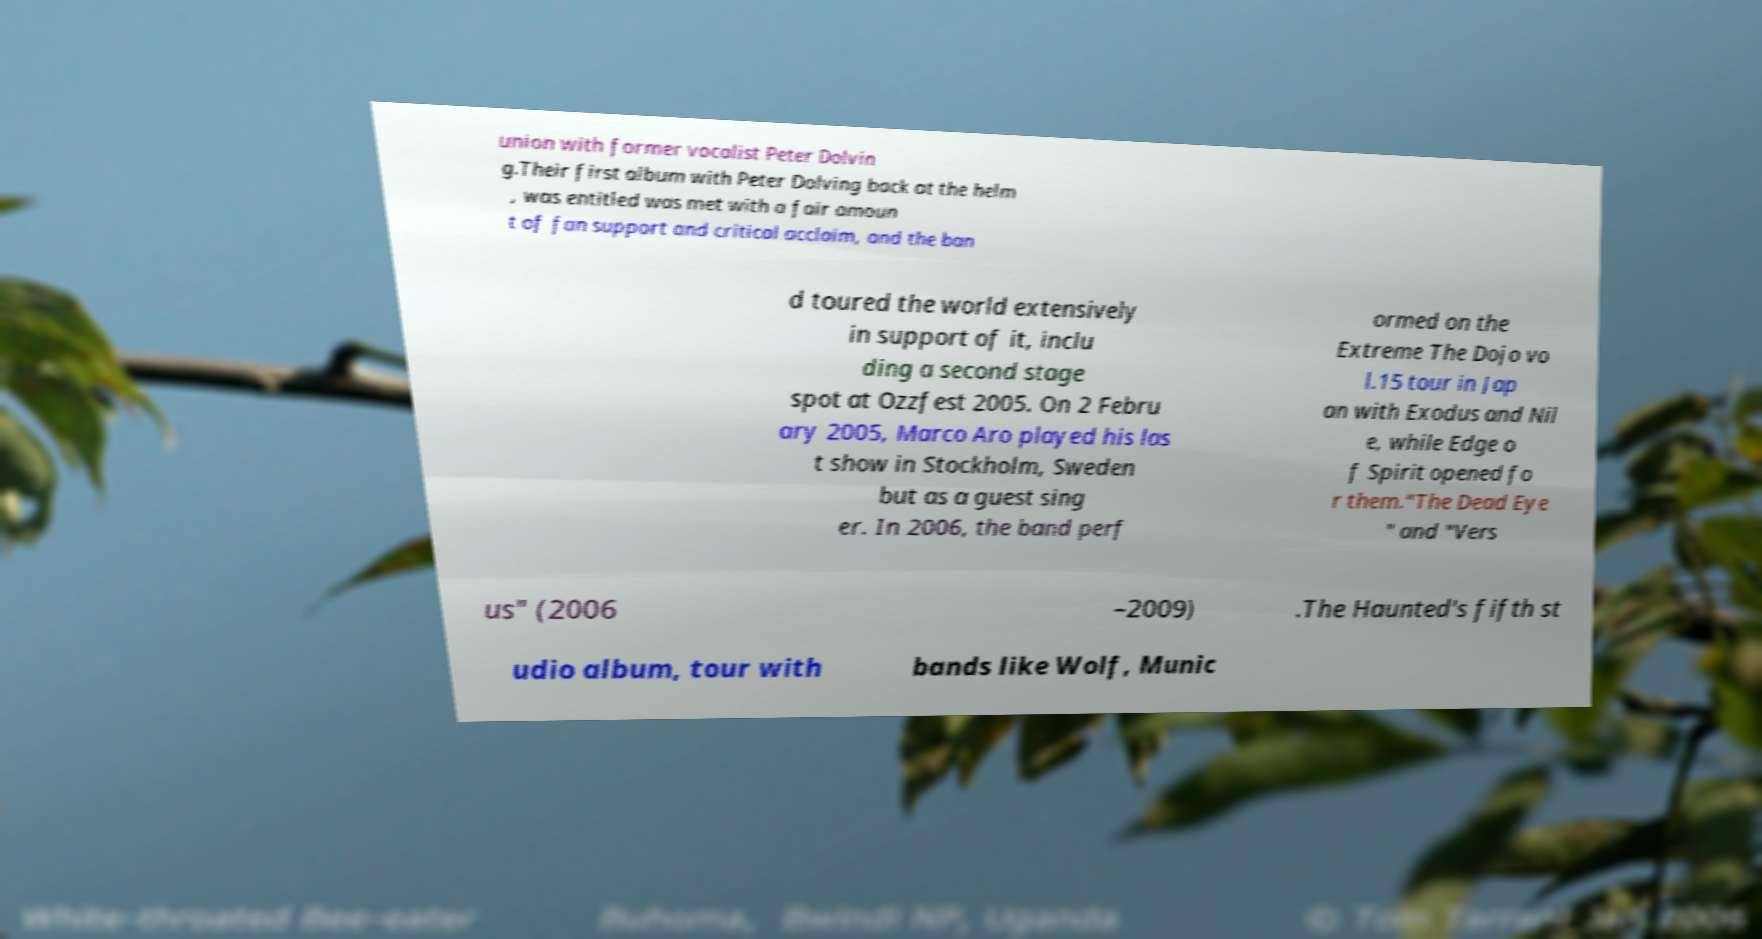What messages or text are displayed in this image? I need them in a readable, typed format. union with former vocalist Peter Dolvin g.Their first album with Peter Dolving back at the helm , was entitled was met with a fair amoun t of fan support and critical acclaim, and the ban d toured the world extensively in support of it, inclu ding a second stage spot at Ozzfest 2005. On 2 Febru ary 2005, Marco Aro played his las t show in Stockholm, Sweden but as a guest sing er. In 2006, the band perf ormed on the Extreme The Dojo vo l.15 tour in Jap an with Exodus and Nil e, while Edge o f Spirit opened fo r them."The Dead Eye " and "Vers us" (2006 –2009) .The Haunted's fifth st udio album, tour with bands like Wolf, Munic 